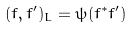<formula> <loc_0><loc_0><loc_500><loc_500>( f , f ^ { \prime } ) _ { L } = \psi ( f ^ { * } f ^ { \prime } )</formula> 